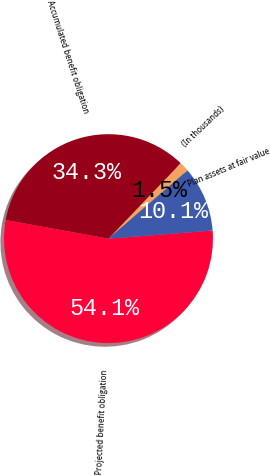Convert chart. <chart><loc_0><loc_0><loc_500><loc_500><pie_chart><fcel>(In thousands)<fcel>Accumulated benefit obligation<fcel>Projected benefit obligation<fcel>Plan assets at fair value<nl><fcel>1.53%<fcel>34.28%<fcel>54.08%<fcel>10.1%<nl></chart> 